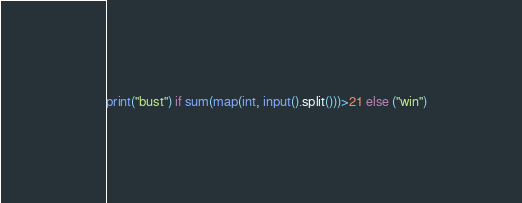Convert code to text. <code><loc_0><loc_0><loc_500><loc_500><_Python_>print("bust") if sum(map(int, input().split()))>21 else ("win")</code> 